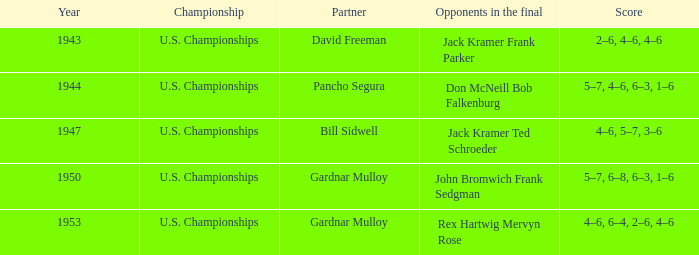What year featured the scores 5-7, 4-6, 6-3, and 1-6? 1944.0. 